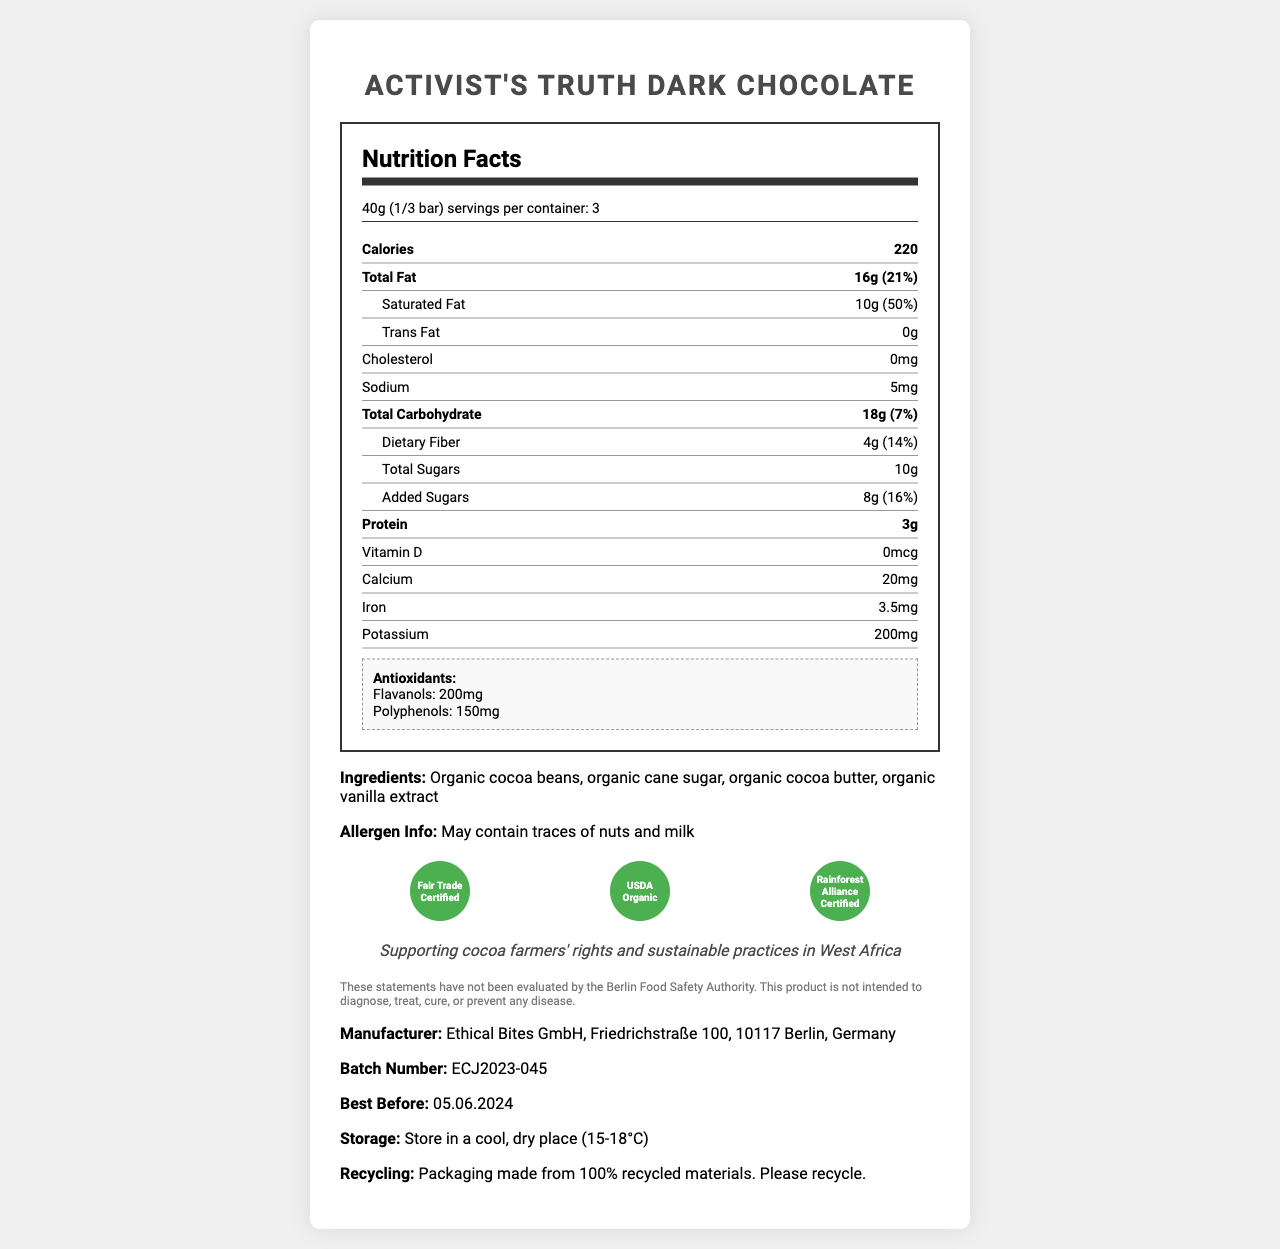what is the serving size of the Activist's Truth Dark Chocolate? The serving size is clearly mentioned in the Nutrition Facts section under the serving info.
Answer: 40g (1/3 bar) how many calories are in one serving of the chocolate bar? According to the nutrition label, one serving contains 220 calories.
Answer: 220 what are the total fats per serving, and their percentage of the daily value? The label shows that the total fat per serving is 16g, which is 21% of the daily value.
Answer: 16g, 21% how much dietary fiber does one serving contain? The document states that dietary fiber per serving is 4g.
Answer: 4g what is the percentage of daily value for iron in one serving? The amount of iron in one serving is 3.5mg, which is 20% of the daily value.
Answer: 20% how many servings are in the entire chocolate bar? The container has 3 servings as mentioned in the label.
Answer: 3 what is the best before date of the chocolate? The best before date is clearly specified at the bottom of the document.
Answer: 05.06.2024 which certifications does the chocolate have? A. Fair Trade Certified B. USDA Organic C. Rainforest Alliance Certified D. All of the above The label mentions that the chocolate has all three certifications: Fair Trade Certified, USDA Organic, and Rainforest Alliance Certified.
Answer: D what is amount of polyphenols in one serving of the chocolate? A. 100mg B. 150mg C. 200mg D. 250mg The antioxidants section states that there are 150mg of polyphenols per serving.
Answer: B does the chocolate contain any trans fat? The label indicates that there is 0g of trans fat in the chocolate.
Answer: No is the sodium content in the chocolate high? The sodium content is 5mg, which is very low.
Answer: No summarize the main idea of this document. The document offers comprehensive information regarding the nutritional value and ethical certifications of the chocolate, ensuring consumers are well-informed about the product.
Answer: The document provides a detailed breakdown of the nutrition facts for Activist's Truth Dark Chocolate, highlighting its fair trade, organic certifications, antioxidant properties, and ethical manufacturing practices. It also includes serving size, nutrient information, ingredient list, allergen information, storage instructions, and manufacturer details. what country is the chocolate manufactured in? The document does not specify the country of manufacture, although the manufacturer's address is in Berlin, Germany. This doesn't necessarily mean the chocolate is manufactured there.
Answer: Not stated 